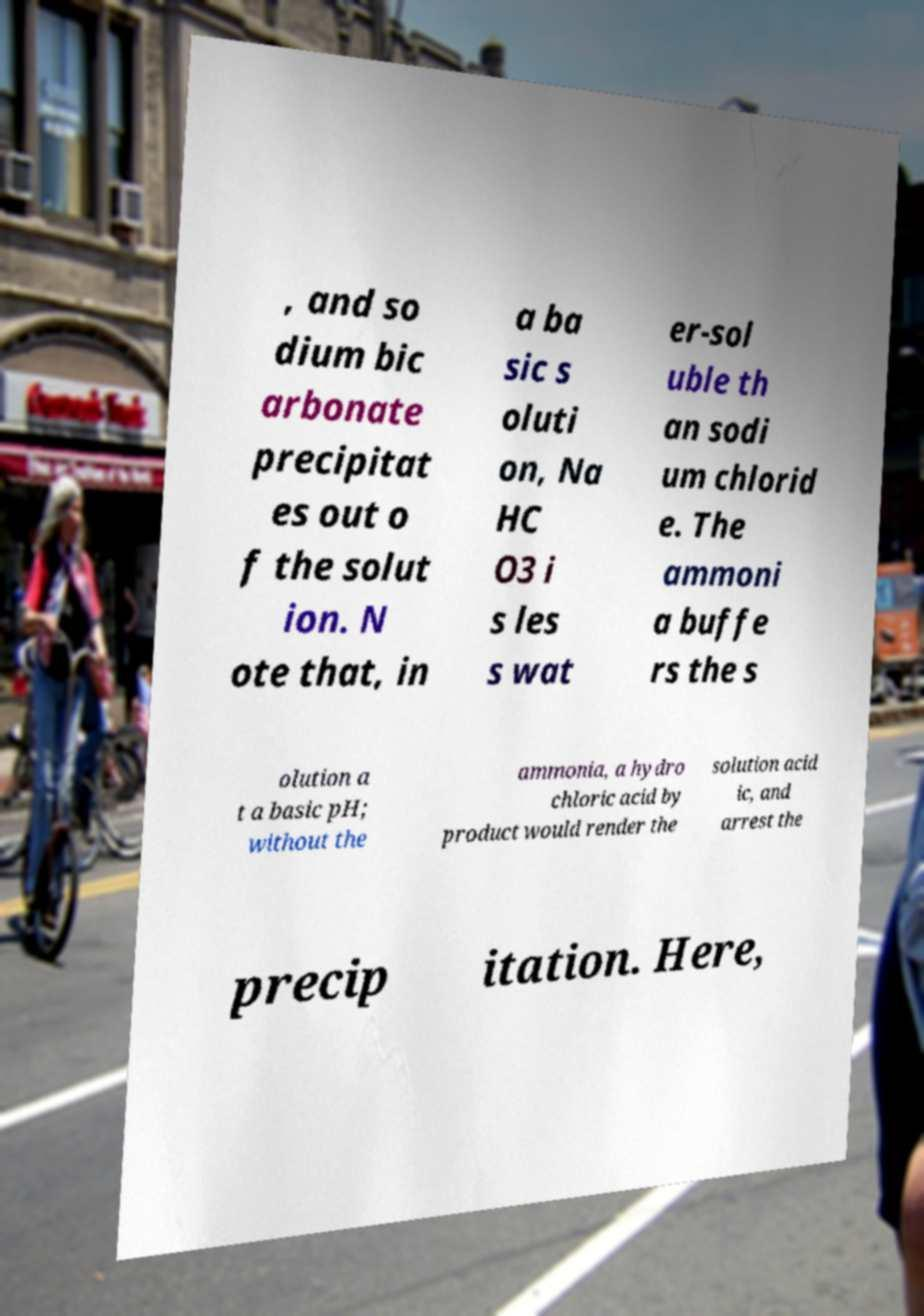Could you assist in decoding the text presented in this image and type it out clearly? , and so dium bic arbonate precipitat es out o f the solut ion. N ote that, in a ba sic s oluti on, Na HC O3 i s les s wat er-sol uble th an sodi um chlorid e. The ammoni a buffe rs the s olution a t a basic pH; without the ammonia, a hydro chloric acid by product would render the solution acid ic, and arrest the precip itation. Here, 